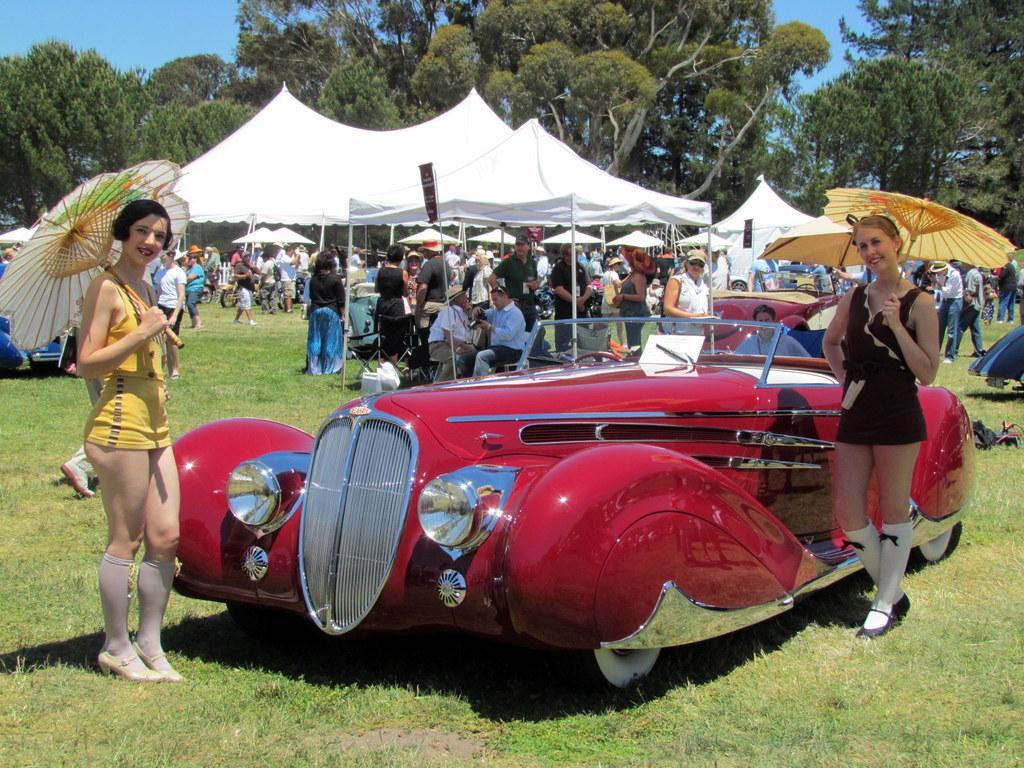Please provide a concise description of this image. In this image in the front there's grass on the ground. In the center there is a car and there is a person sitting in the car which is red in colour. In front of the car there are persons standing and smiling and holding umbrella. In the background there are tents which are white in colour and there are persons sitting and standing and walking and there are trees and there are vehicles. 